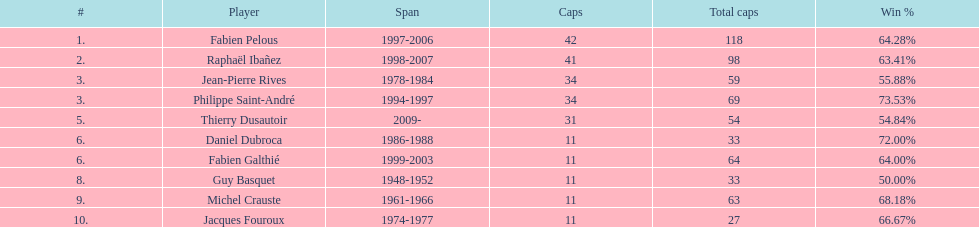Whose win percentage was the greatest? Philippe Saint-André. 